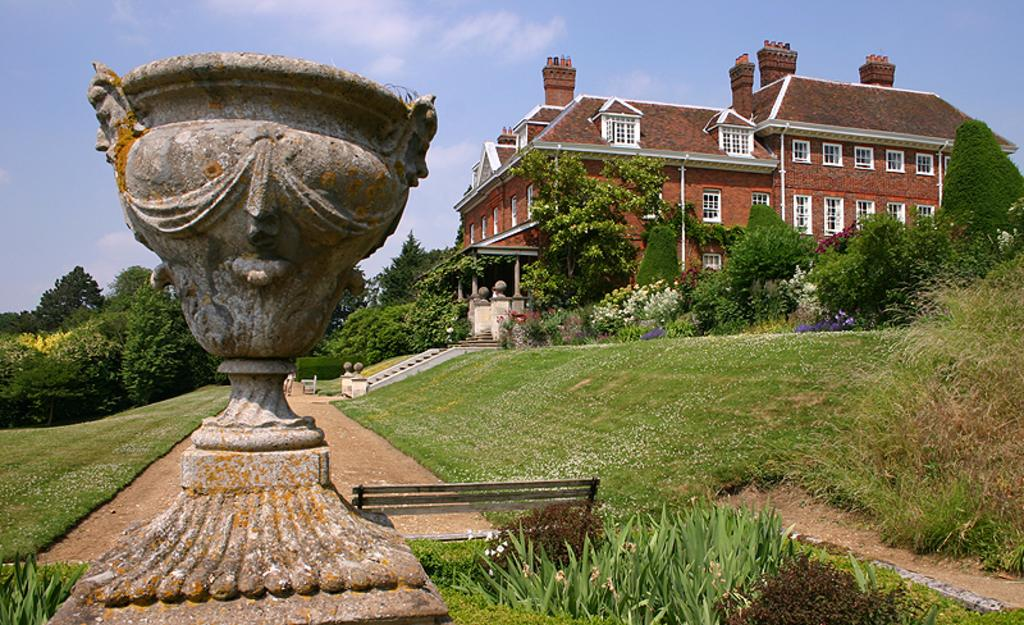What is: What type of structure is present in the image? There is a rock structure in the image. What is located beside the rock structure? There is a bench beside the rock structure. What type of vegetation can be seen in the image? There are trees, plants, grass, and flowers in the image. Can you describe the background of the image? The sky is visible in the background of the image. Are there any man-made structures in the image? Yes, there is a building in the image. How many giraffes can be seen in the image? There are no giraffes present in the image. What type of order is being followed by the plants in the image? The plants in the image are not following any specific order; they are randomly distributed. 